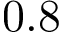Convert formula to latex. <formula><loc_0><loc_0><loc_500><loc_500>0 . 8</formula> 